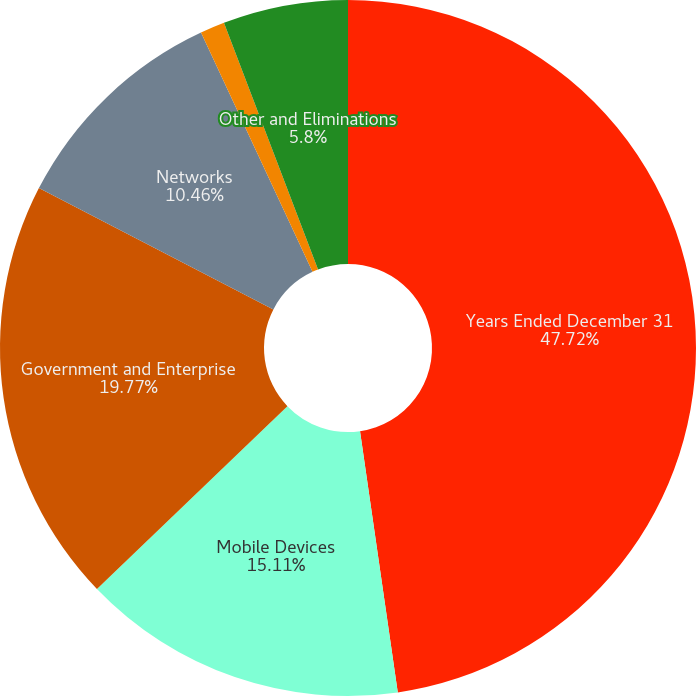Convert chart to OTSL. <chart><loc_0><loc_0><loc_500><loc_500><pie_chart><fcel>Years Ended December 31<fcel>Mobile Devices<fcel>Government and Enterprise<fcel>Networks<fcel>Connected Home Solutions<fcel>Other and Eliminations<nl><fcel>47.71%<fcel>15.11%<fcel>19.77%<fcel>10.46%<fcel>1.14%<fcel>5.8%<nl></chart> 